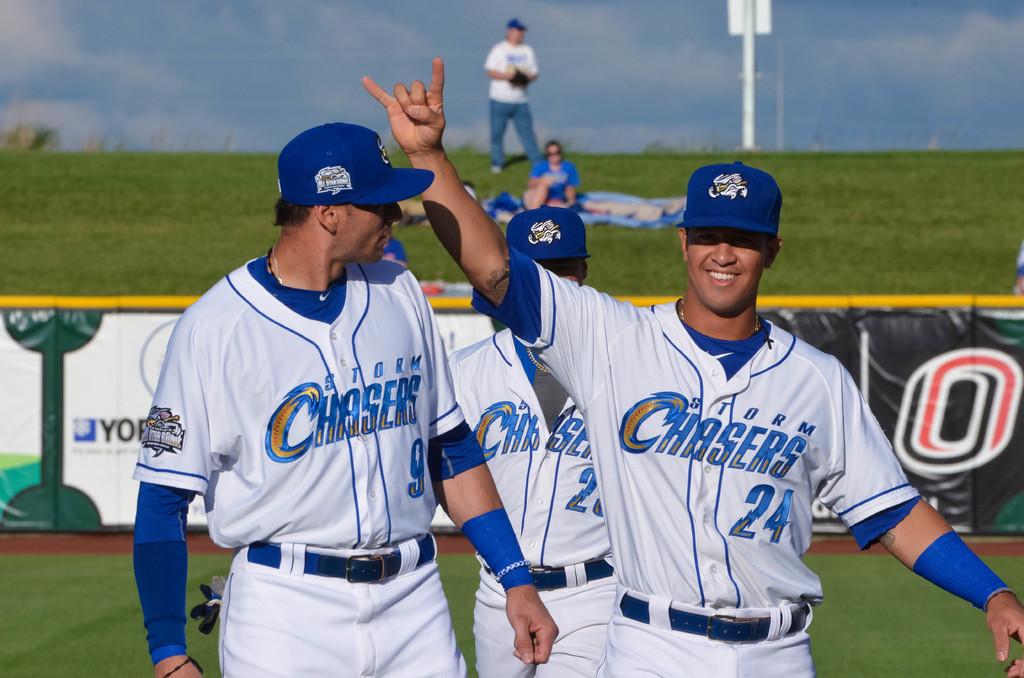Which club do they play for?
Keep it short and to the point. Storm chasers. 